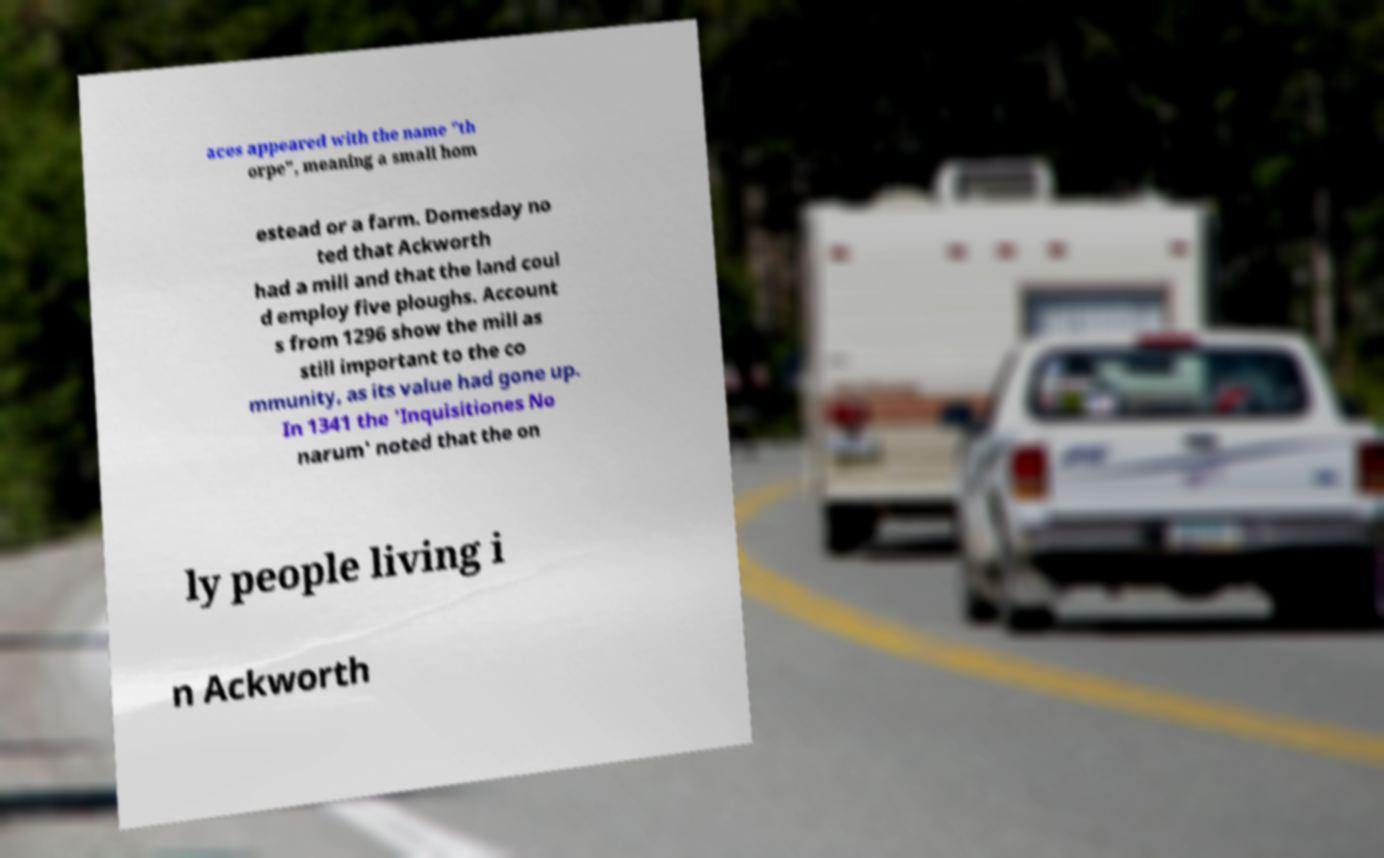For documentation purposes, I need the text within this image transcribed. Could you provide that? aces appeared with the name "th orpe", meaning a small hom estead or a farm. Domesday no ted that Ackworth had a mill and that the land coul d employ five ploughs. Account s from 1296 show the mill as still important to the co mmunity, as its value had gone up. In 1341 the 'Inquisitiones No narum' noted that the on ly people living i n Ackworth 